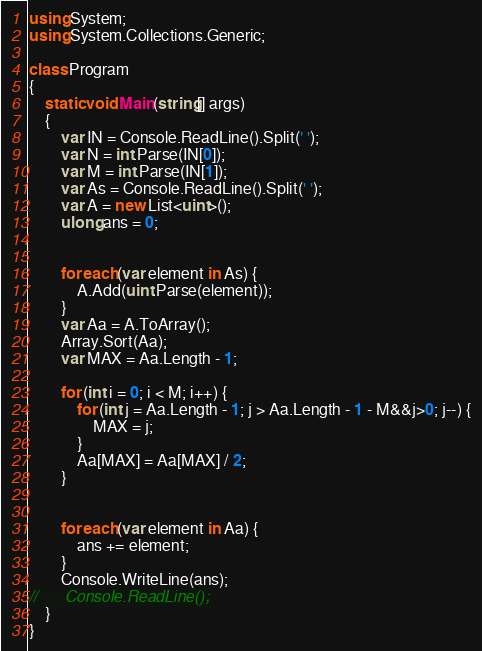Convert code to text. <code><loc_0><loc_0><loc_500><loc_500><_C#_>using System;
using System.Collections.Generic;

class Program
{
	static void Main(string[] args)
	{
		var IN = Console.ReadLine().Split(' ');
		var N = int.Parse(IN[0]);
		var M = int.Parse(IN[1]);
		var As = Console.ReadLine().Split(' ');
		var A = new List<uint>();
		ulong ans = 0;
		
		
		foreach (var element in As) {
			A.Add(uint.Parse(element));
		}
		var Aa = A.ToArray();
		Array.Sort(Aa);
		var MAX = Aa.Length - 1;

		for (int i = 0; i < M; i++) {
			for (int j = Aa.Length - 1; j > Aa.Length - 1 - M&&j>0; j--) {
				MAX = j;
			}
			Aa[MAX] = Aa[MAX] / 2;
		}
		
		
		foreach (var element in Aa) {
			ans += element;
		}
		Console.WriteLine(ans);
//		Console.ReadLine();
	}
}</code> 